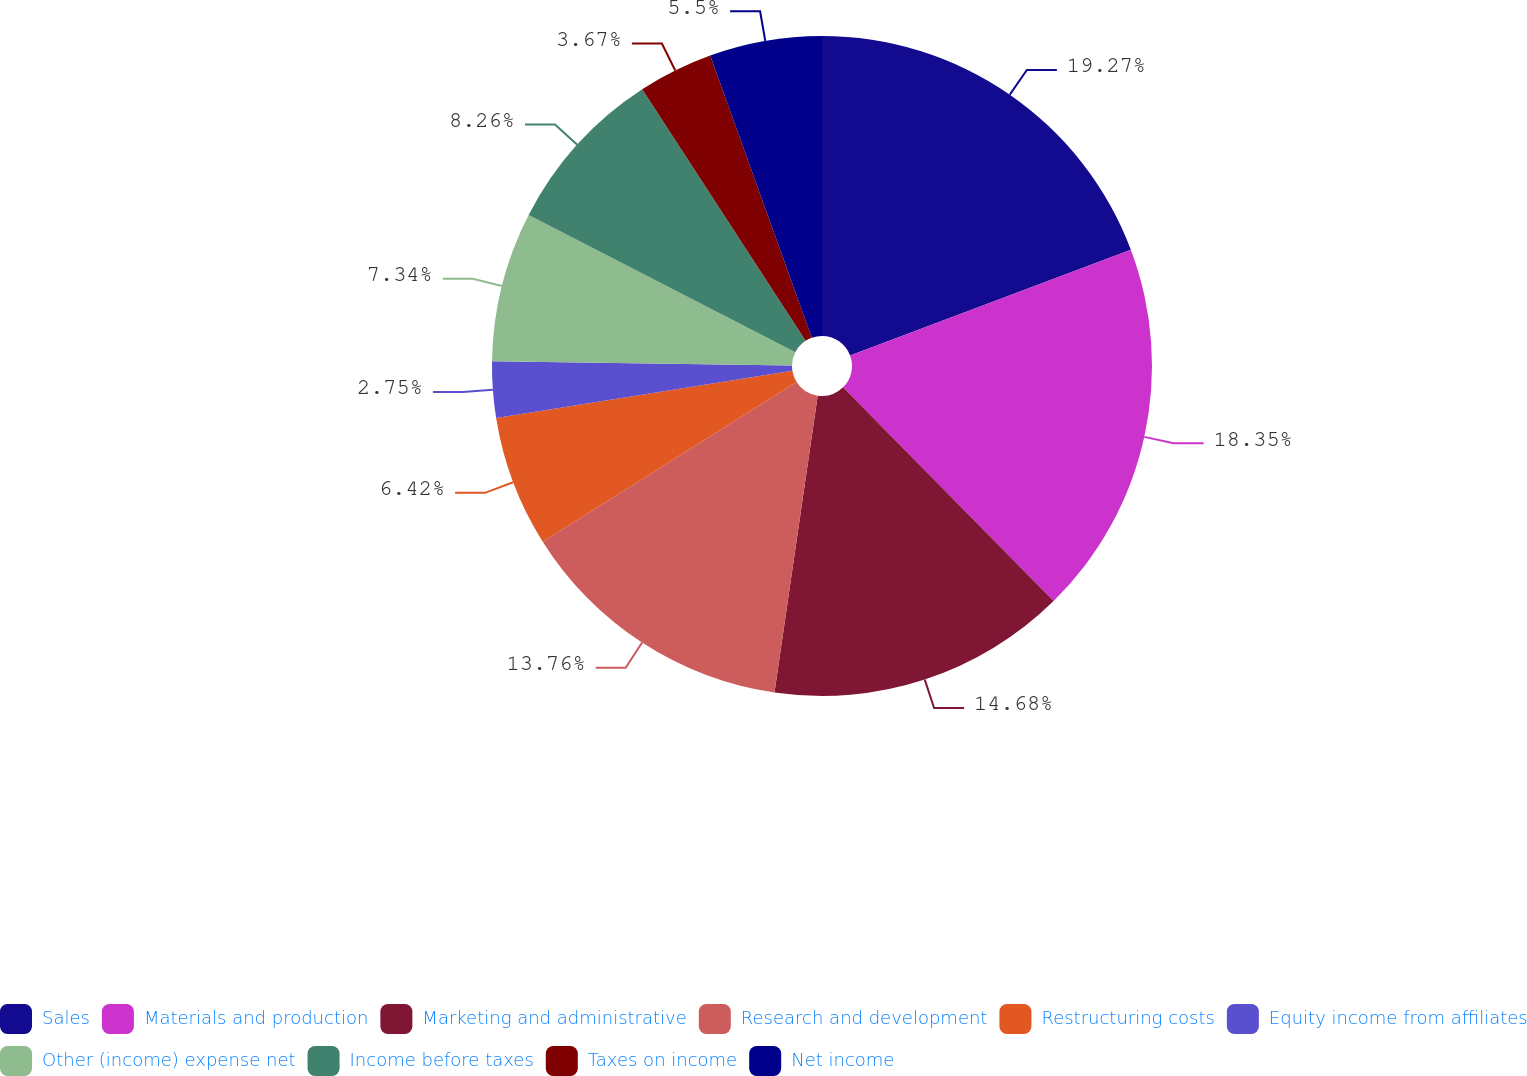<chart> <loc_0><loc_0><loc_500><loc_500><pie_chart><fcel>Sales<fcel>Materials and production<fcel>Marketing and administrative<fcel>Research and development<fcel>Restructuring costs<fcel>Equity income from affiliates<fcel>Other (income) expense net<fcel>Income before taxes<fcel>Taxes on income<fcel>Net income<nl><fcel>19.27%<fcel>18.35%<fcel>14.68%<fcel>13.76%<fcel>6.42%<fcel>2.75%<fcel>7.34%<fcel>8.26%<fcel>3.67%<fcel>5.5%<nl></chart> 